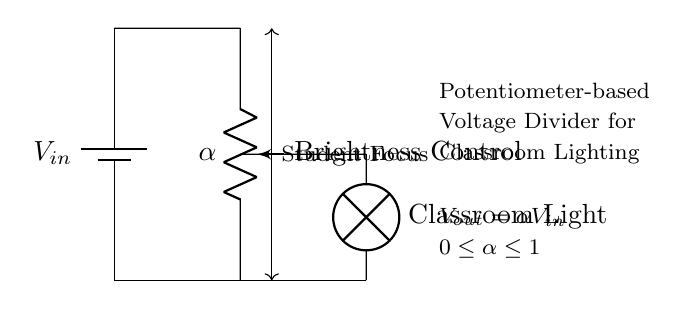What is the input voltage in the circuit? The circuit diagram indicates an input voltage labeled as V in, which typically represents the voltage supplied by the battery. However, the specific value is not provided in the diagram, so we cannot definitively state it.
Answer: V in What component is used to control brightness? The component labeled as "Brightness Control" in the diagram is a potentiometer, which adjusts the voltage output and consequently the brightness of the lamp.
Answer: Potentiometer What is the output voltage equation in this circuit? The diagram states that the output voltage, represented as V out, is equal to alpha multiplied by V in, indicating the relationship between input and output voltages based on the potentiometer setting.
Answer: V out = alpha V in How does adjusting the potentiometer affect student focus? Adjusting the potentiometer allows for changes in the output voltage, which in turn controls the brightness of the classroom light, affecting the visual environment and potentially impacting student focus.
Answer: It controls brightness What is the range of alpha in the circuit? The circuit diagram provides a note indicating that alpha (the potentiometer setting) ranges from 0 to 1. This means it can vary from minimum to maximum brightness.
Answer: 0 to 1 What type of circuit is depicted here? The circuit uses a potentiometer to create a voltage divider for controlling the brightness of a lamp, which is a specific application of a voltage divider circuit.
Answer: Voltage divider 